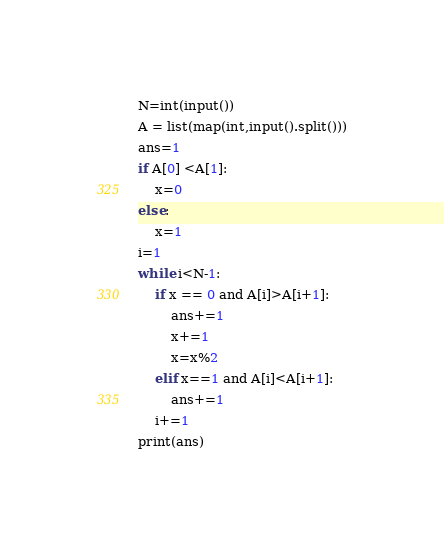<code> <loc_0><loc_0><loc_500><loc_500><_Python_>N=int(input())
A = list(map(int,input().split()))
ans=1
if A[0] <A[1]:
    x=0
else:
    x=1
i=1
while i<N-1:
    if x == 0 and A[i]>A[i+1]:
        ans+=1
        x+=1
        x=x%2
    elif x==1 and A[i]<A[i+1]:
        ans+=1
    i+=1
print(ans)</code> 